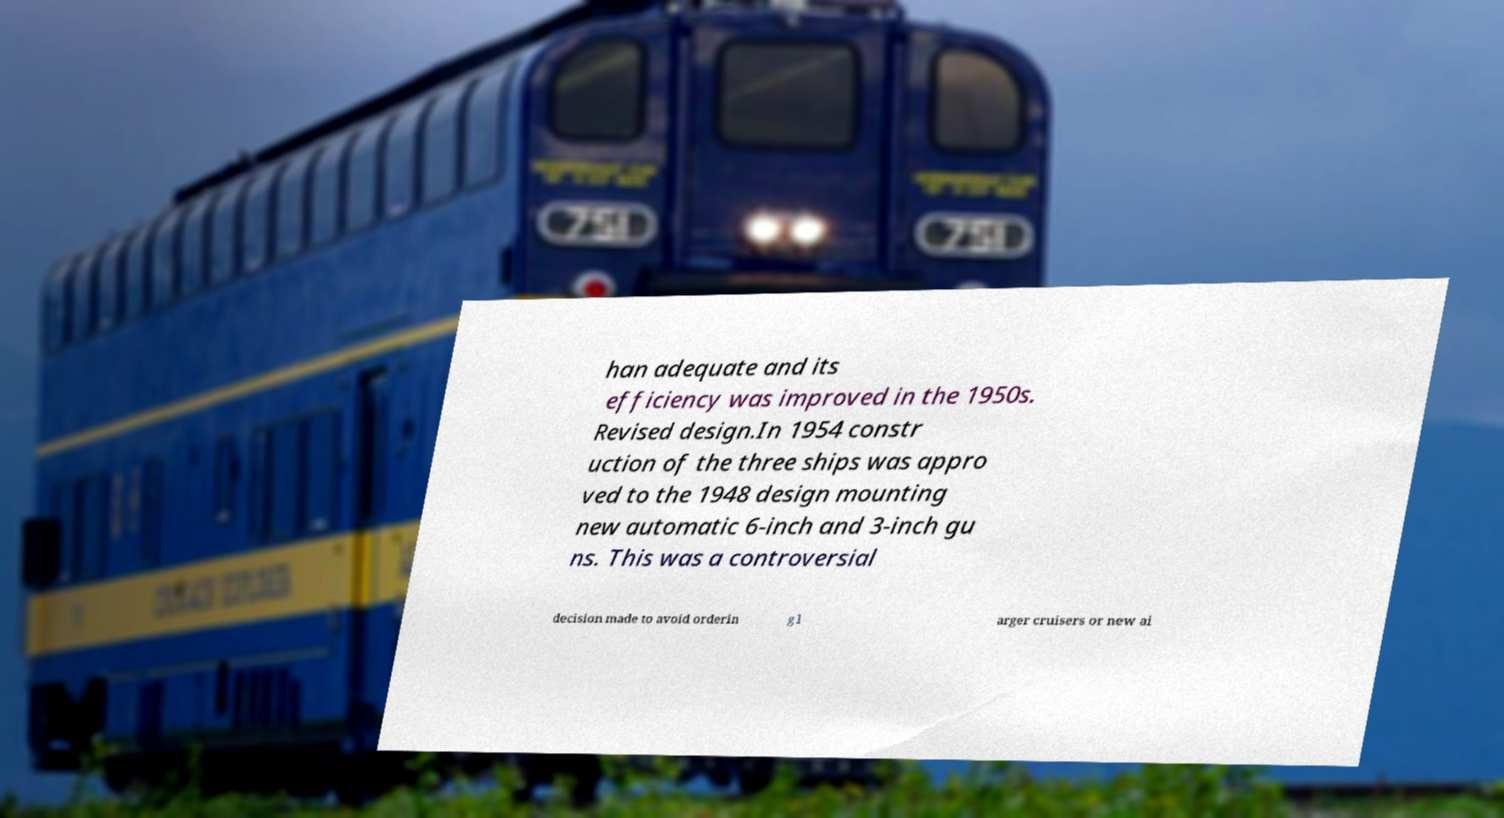Could you extract and type out the text from this image? han adequate and its efficiency was improved in the 1950s. Revised design.In 1954 constr uction of the three ships was appro ved to the 1948 design mounting new automatic 6-inch and 3-inch gu ns. This was a controversial decision made to avoid orderin g l arger cruisers or new ai 